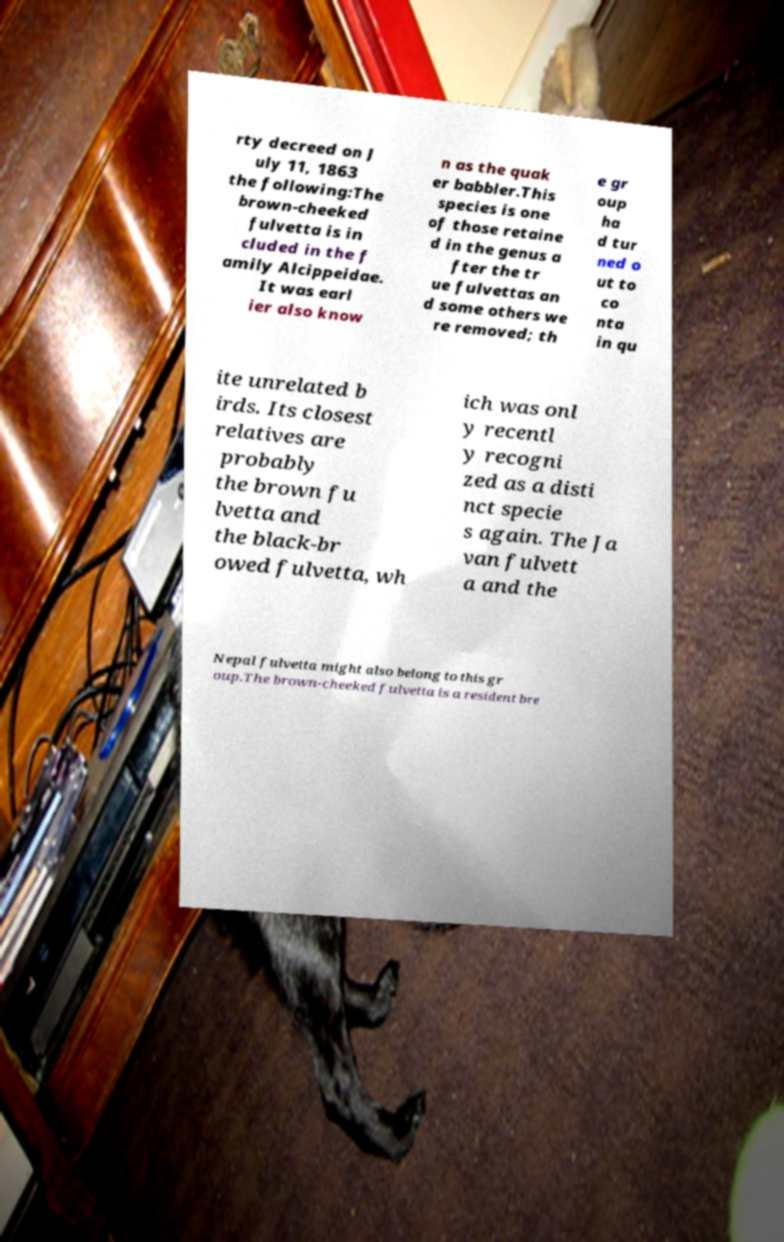Could you extract and type out the text from this image? rty decreed on J uly 11, 1863 the following:The brown-cheeked fulvetta is in cluded in the f amily Alcippeidae. It was earl ier also know n as the quak er babbler.This species is one of those retaine d in the genus a fter the tr ue fulvettas an d some others we re removed; th e gr oup ha d tur ned o ut to co nta in qu ite unrelated b irds. Its closest relatives are probably the brown fu lvetta and the black-br owed fulvetta, wh ich was onl y recentl y recogni zed as a disti nct specie s again. The Ja van fulvett a and the Nepal fulvetta might also belong to this gr oup.The brown-cheeked fulvetta is a resident bre 